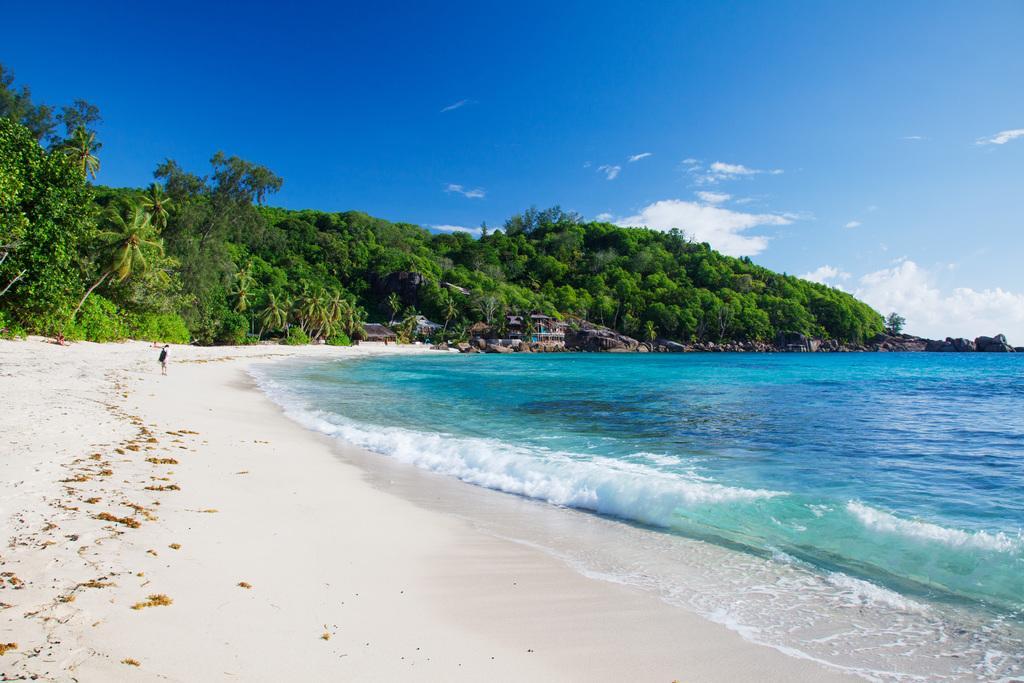Could you give a brief overview of what you see in this image? At the bottom of the image on the left side there is a person standing on the seashore. And on the right side of the image there is water. In the background there are trees and also there are few buildings. At the top of the image there is sky with clouds. 